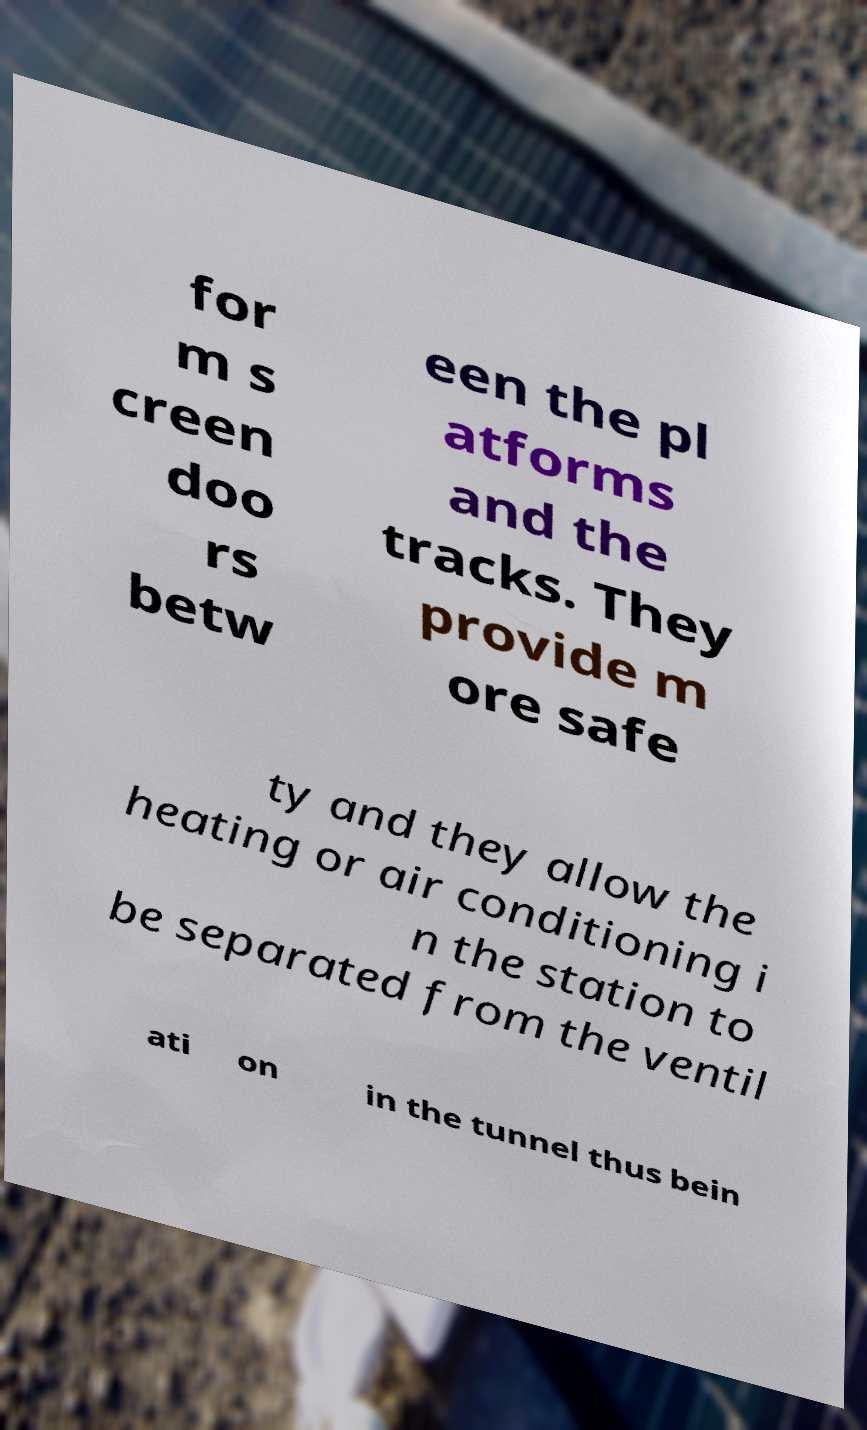Please read and relay the text visible in this image. What does it say? for m s creen doo rs betw een the pl atforms and the tracks. They provide m ore safe ty and they allow the heating or air conditioning i n the station to be separated from the ventil ati on in the tunnel thus bein 